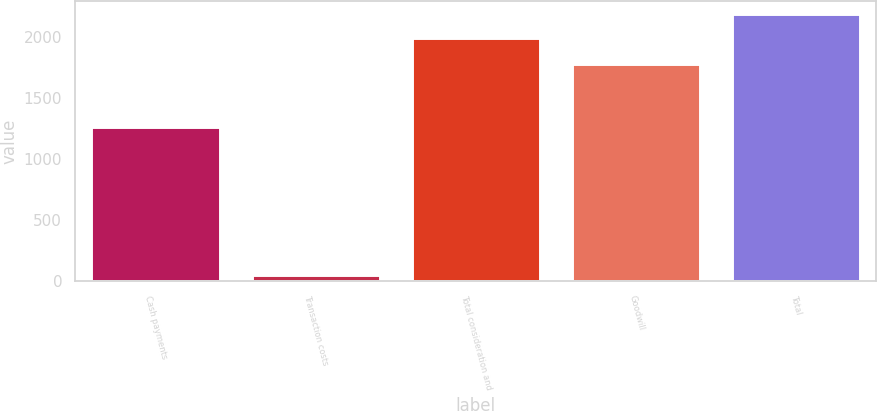<chart> <loc_0><loc_0><loc_500><loc_500><bar_chart><fcel>Cash payments<fcel>Transaction costs<fcel>Total consideration and<fcel>Goodwill<fcel>Total<nl><fcel>1259<fcel>50<fcel>1989<fcel>1778<fcel>2182.9<nl></chart> 